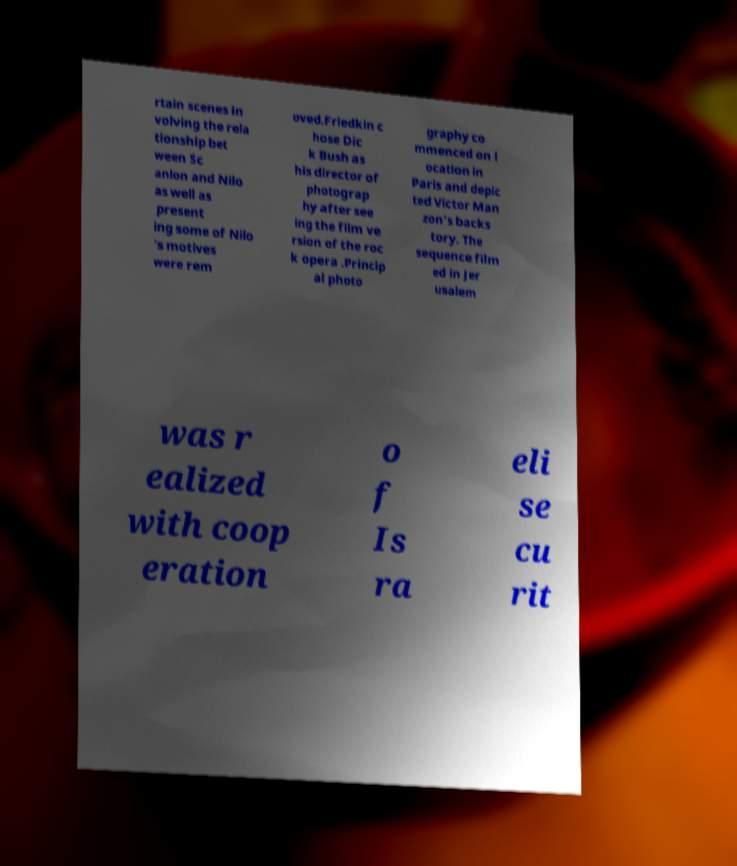For documentation purposes, I need the text within this image transcribed. Could you provide that? rtain scenes in volving the rela tionship bet ween Sc anlon and Nilo as well as present ing some of Nilo 's motives were rem oved.Friedkin c hose Dic k Bush as his director of photograp hy after see ing the film ve rsion of the roc k opera .Princip al photo graphy co mmenced on l ocation in Paris and depic ted Victor Man zon's backs tory. The sequence film ed in Jer usalem was r ealized with coop eration o f Is ra eli se cu rit 